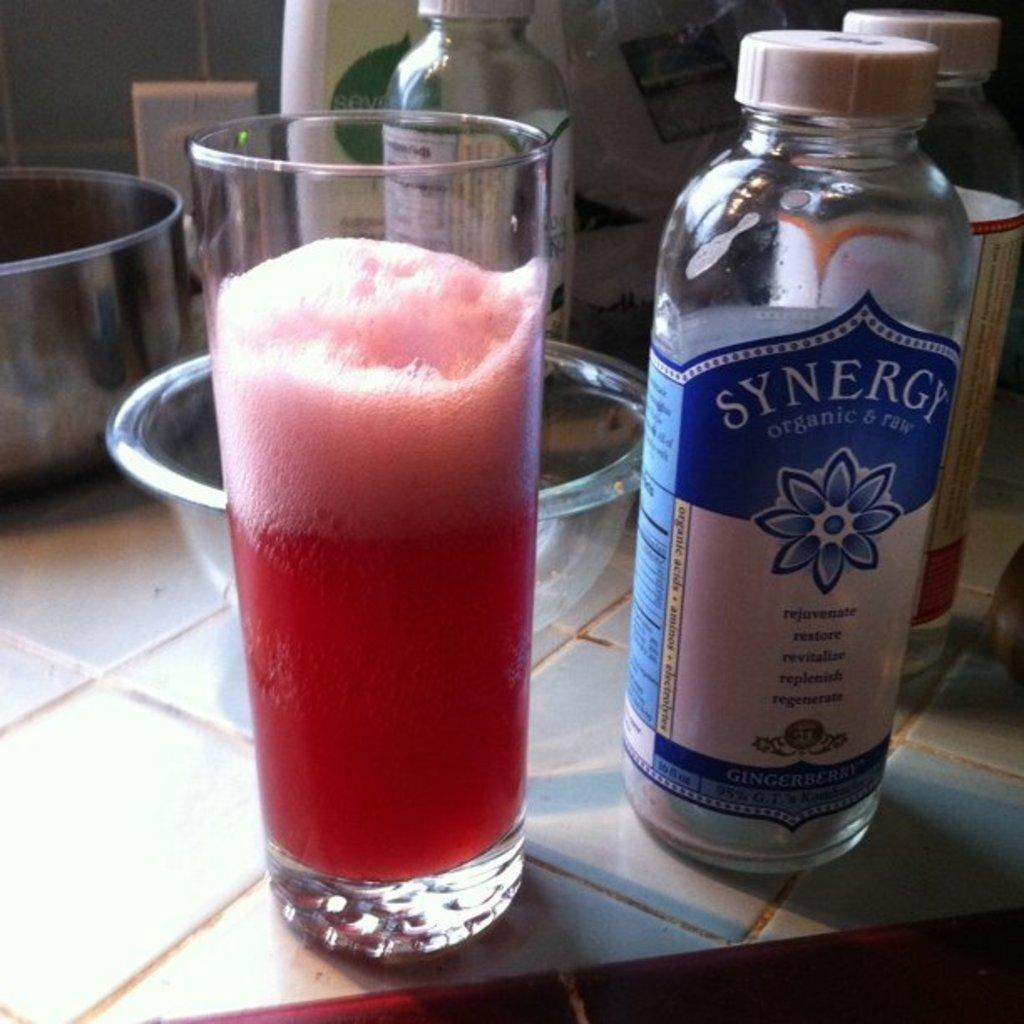Provide a one-sentence caption for the provided image. A bottle of Synergy sits on counter next to glass with a pink beverage. 